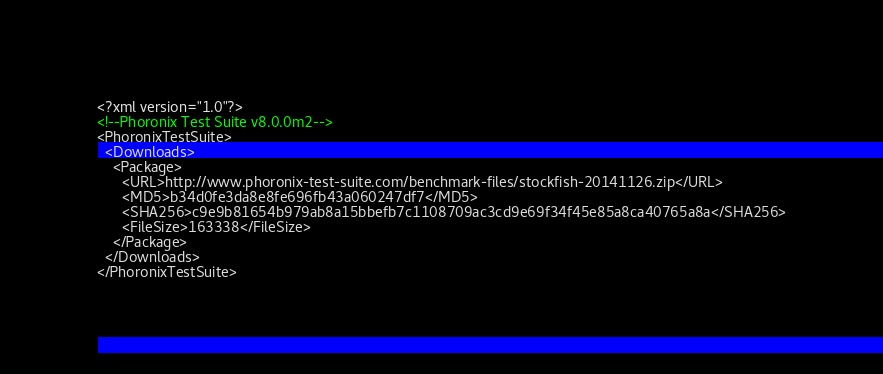Convert code to text. <code><loc_0><loc_0><loc_500><loc_500><_XML_><?xml version="1.0"?>
<!--Phoronix Test Suite v8.0.0m2-->
<PhoronixTestSuite>
  <Downloads>
    <Package>
      <URL>http://www.phoronix-test-suite.com/benchmark-files/stockfish-20141126.zip</URL>
      <MD5>b34d0fe3da8e8fe696fb43a060247df7</MD5>
      <SHA256>c9e9b81654b979ab8a15bbefb7c1108709ac3cd9e69f34f45e85a8ca40765a8a</SHA256>
      <FileSize>163338</FileSize>
    </Package>
  </Downloads>
</PhoronixTestSuite>
</code> 